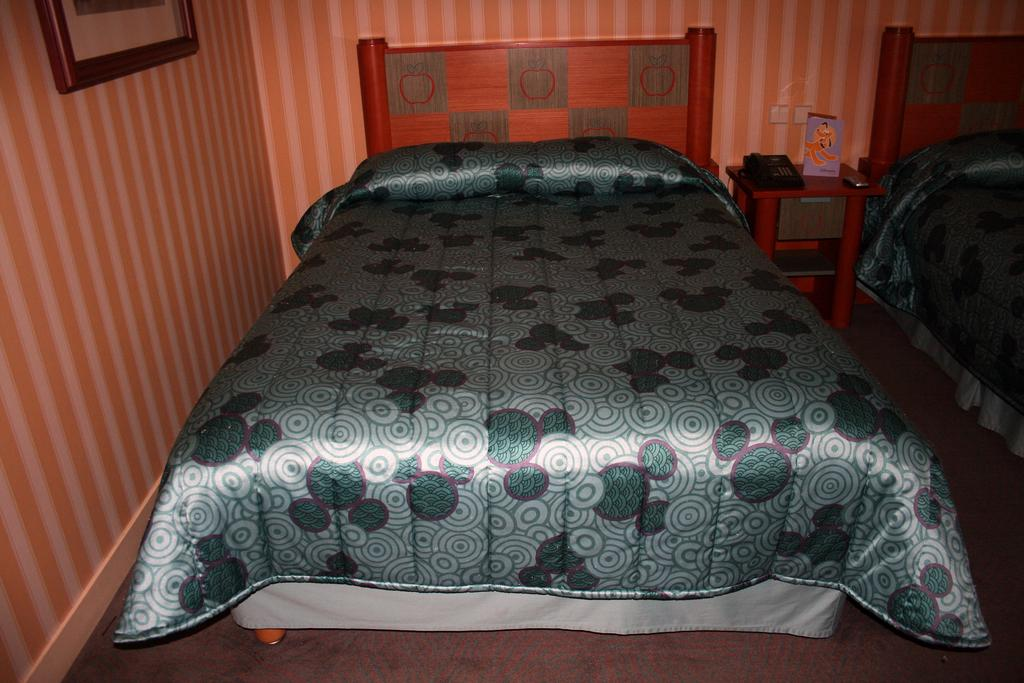What type of furniture is present in the image? There are beds, pillows, and blankets in the image. What is the purpose of the telephone in the image? The telephone is likely for communication purposes. What can be found on the cupboard in the image? There are objects on the cupboard in the image. How is the frame attached to the wall in the image? The frame is attached to the wall in the image. Can you see an island in the image? There is no island present in the image. How does the back of the bed look in the image? The provided facts do not mention the back of the bed, so it cannot be determined from the image. 